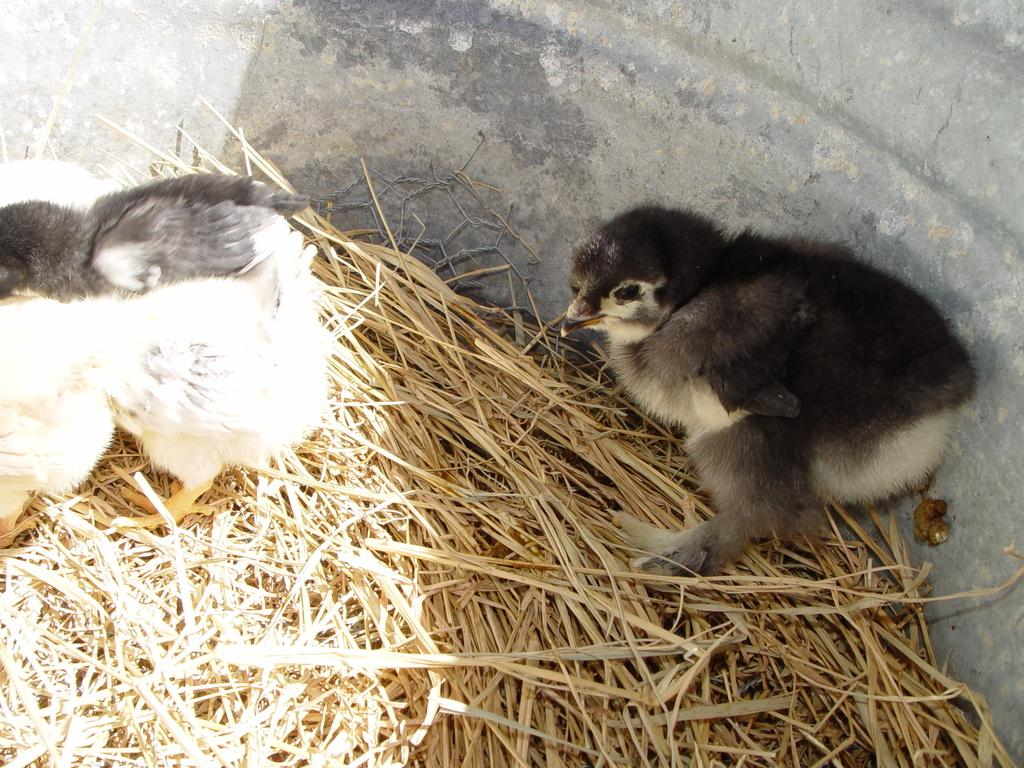How many birds are present in the image? There are two birds in the image. What type of vegetation is visible in the image? There is dry grass in the image. Where are the birds and grass located? The birds and grass appear to be in a pot. What is the position of the birds in relation to the grass in the image? There is no specific position mentioned in the image; the birds and grass are simply present in the pot. 